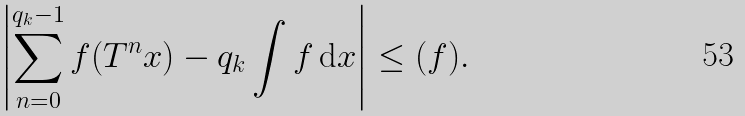Convert formula to latex. <formula><loc_0><loc_0><loc_500><loc_500>\left | \sum _ { n = 0 } ^ { q _ { k } - 1 } f ( T ^ { n } x ) - q _ { k } \int f \, { \mathrm d } x \right | \leq ( f ) .</formula> 